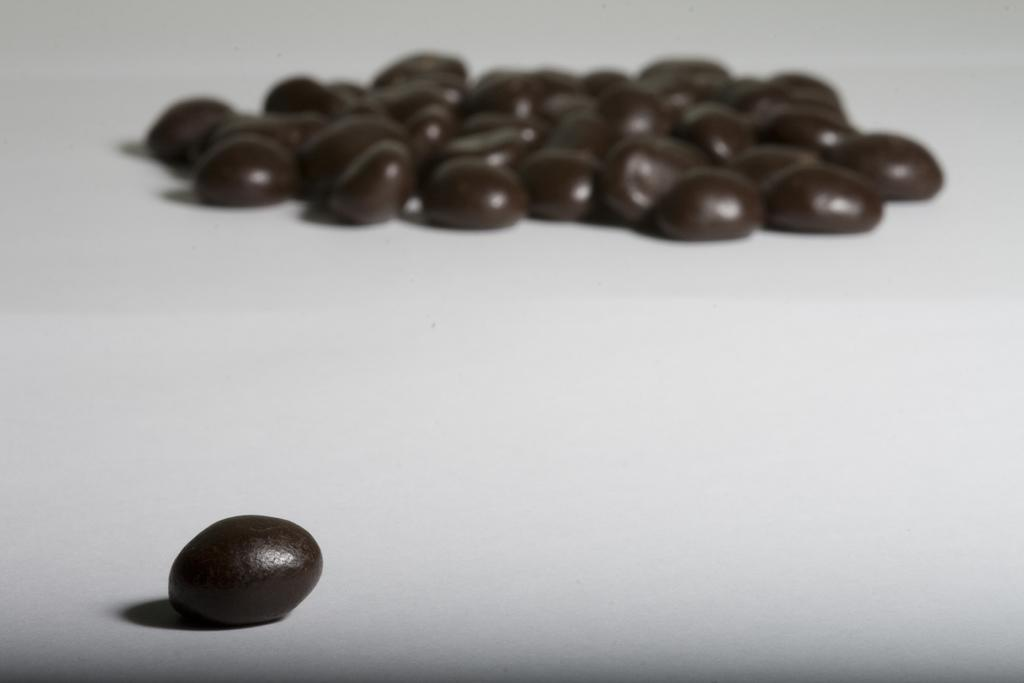What color are the objects in the image? The objects in the image are black. What color is the surface on which the objects are placed? The surface is white. What position do the dolls take in the image? There are no dolls present in the image. 